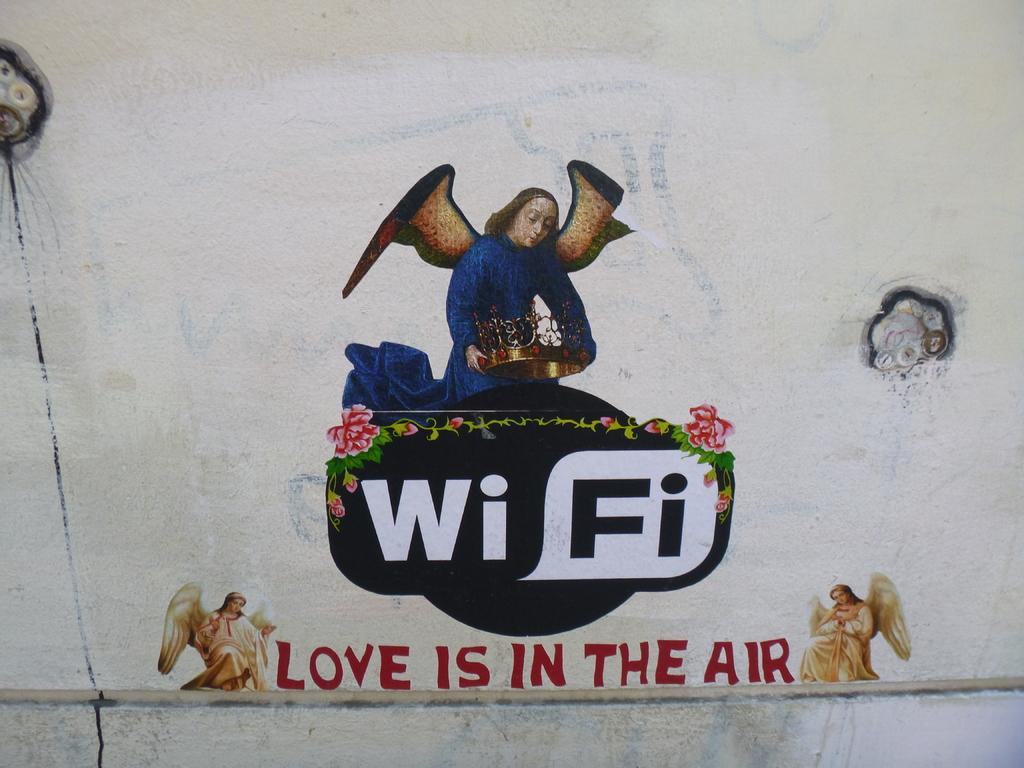What is on the wall in the image? There is a painting on the wall in the image. What is the subject matter of the painting? The painting depicts people and flowers. Are there any words or letters in the painting? Yes, there is text present in the painting. Can you see a frog jumping in the painting? There is no frog present in the painting; it depicts people and flowers. How many bags of popcorn are visible in the painting? There are no bags of popcorn present in the painting; it only includes people, flowers, and text. 